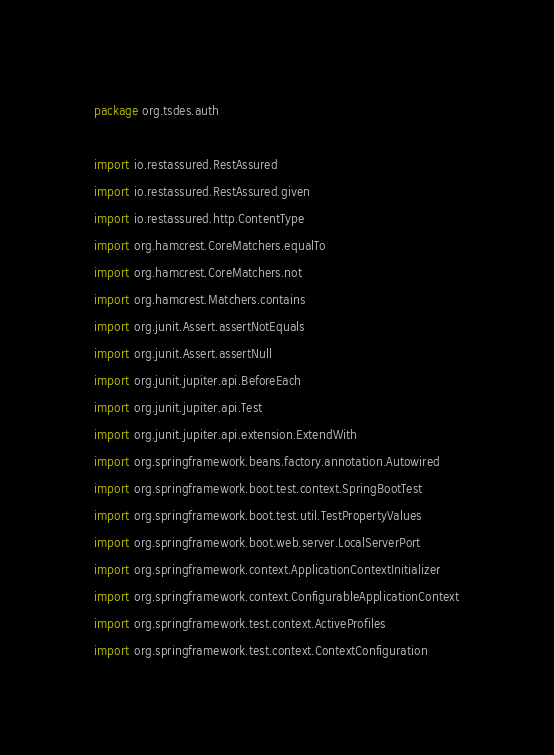Convert code to text. <code><loc_0><loc_0><loc_500><loc_500><_Kotlin_>package org.tsdes.auth

import io.restassured.RestAssured
import io.restassured.RestAssured.given
import io.restassured.http.ContentType
import org.hamcrest.CoreMatchers.equalTo
import org.hamcrest.CoreMatchers.not
import org.hamcrest.Matchers.contains
import org.junit.Assert.assertNotEquals
import org.junit.Assert.assertNull
import org.junit.jupiter.api.BeforeEach
import org.junit.jupiter.api.Test
import org.junit.jupiter.api.extension.ExtendWith
import org.springframework.beans.factory.annotation.Autowired
import org.springframework.boot.test.context.SpringBootTest
import org.springframework.boot.test.util.TestPropertyValues
import org.springframework.boot.web.server.LocalServerPort
import org.springframework.context.ApplicationContextInitializer
import org.springframework.context.ConfigurableApplicationContext
import org.springframework.test.context.ActiveProfiles
import org.springframework.test.context.ContextConfiguration</code> 